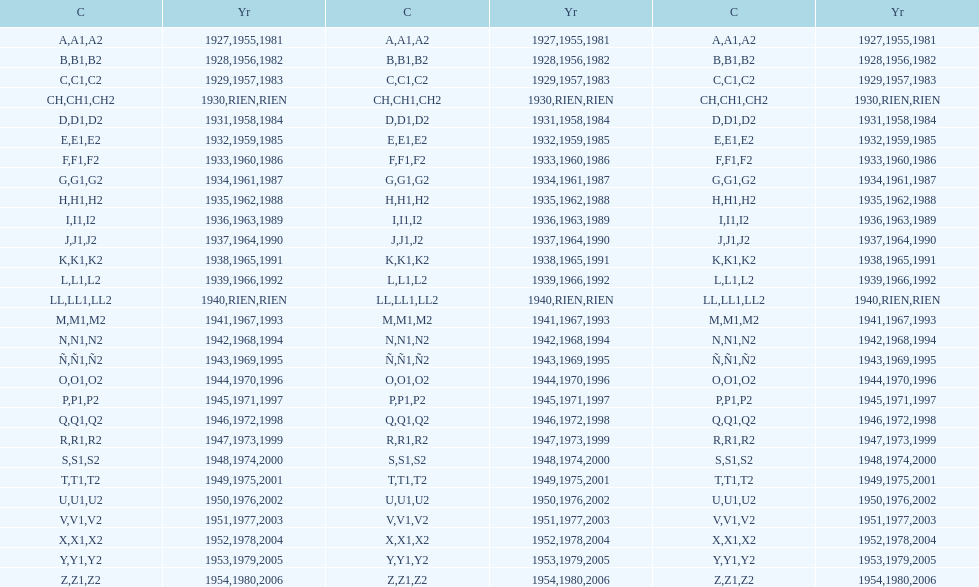Other than 1927 what year did the code start with a? 1955, 1981. 